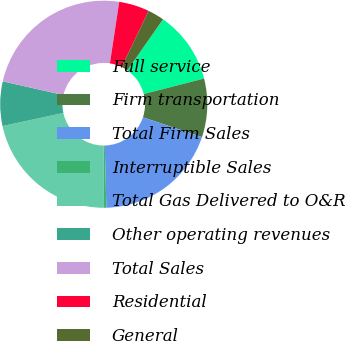Convert chart to OTSL. <chart><loc_0><loc_0><loc_500><loc_500><pie_chart><fcel>Full service<fcel>Firm transportation<fcel>Total Firm Sales<fcel>Interruptible Sales<fcel>Total Gas Delivered to O&R<fcel>Other operating revenues<fcel>Total Sales<fcel>Residential<fcel>General<nl><fcel>11.32%<fcel>9.13%<fcel>19.46%<fcel>0.37%<fcel>21.65%<fcel>6.94%<fcel>23.84%<fcel>4.75%<fcel>2.56%<nl></chart> 